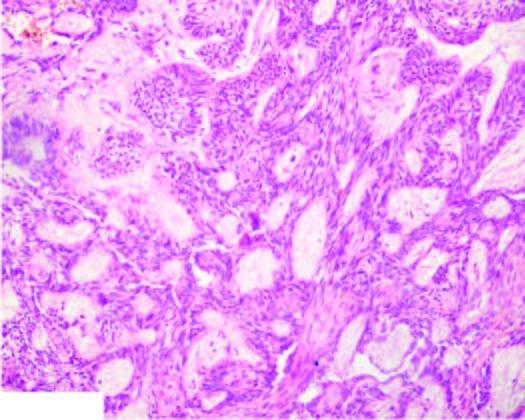what are composed of central area of stellate cells and peripheral layer of cuboidal or columnar cells?
Answer the question using a single word or phrase. Epithelial follicles 